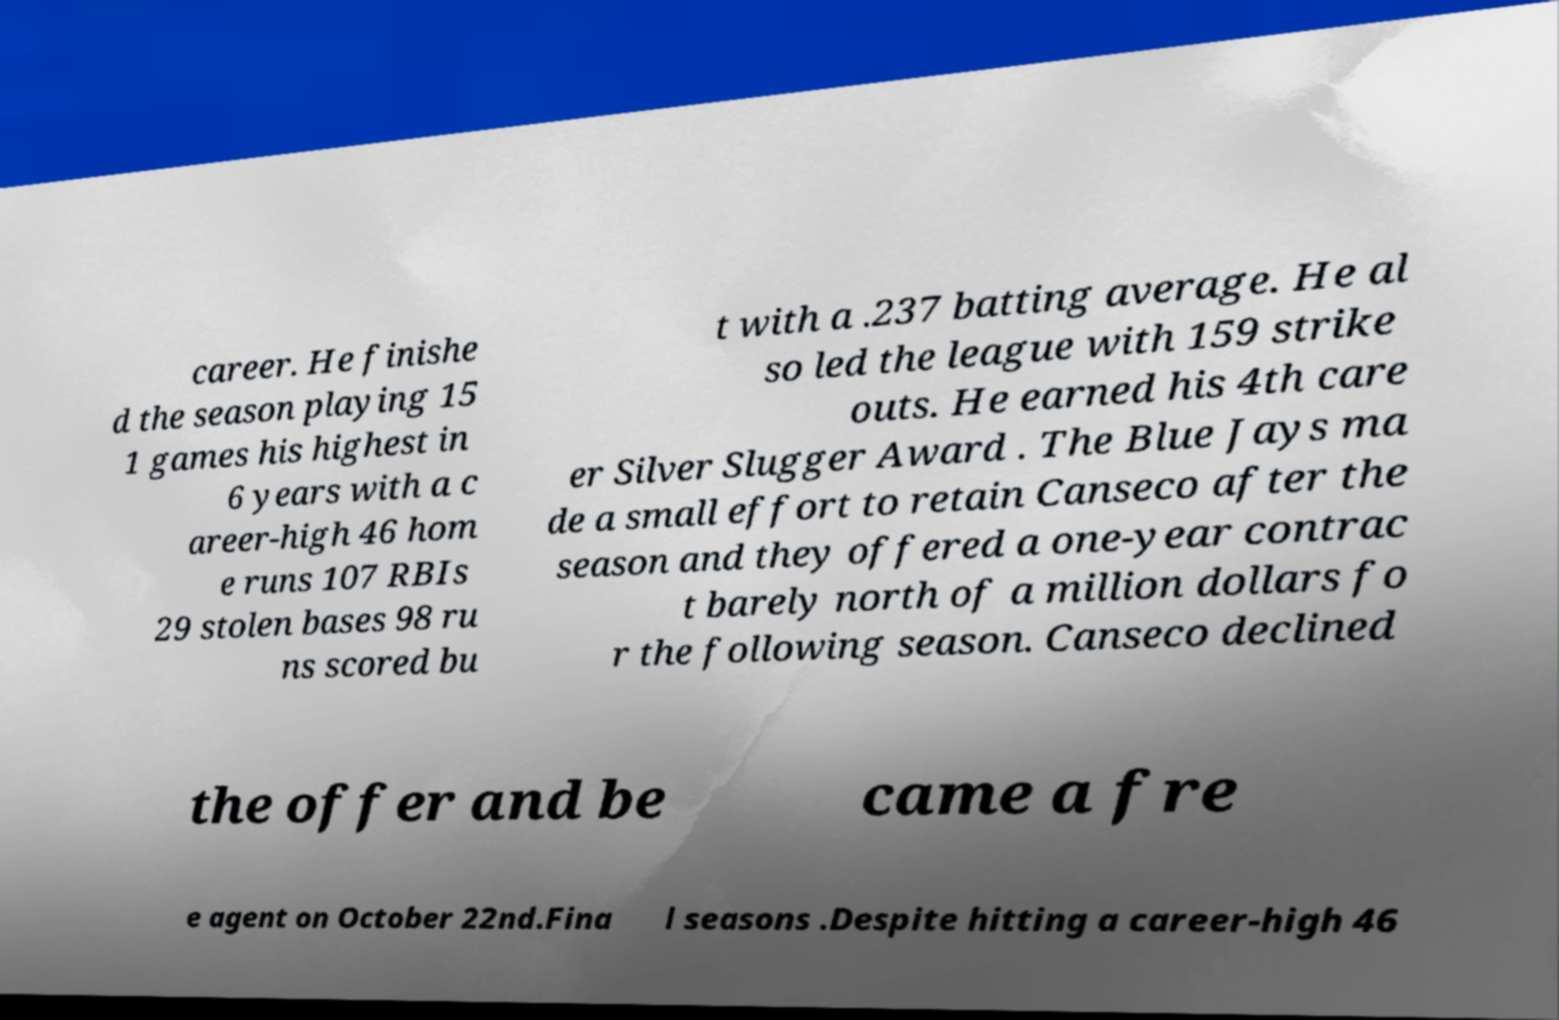I need the written content from this picture converted into text. Can you do that? career. He finishe d the season playing 15 1 games his highest in 6 years with a c areer-high 46 hom e runs 107 RBIs 29 stolen bases 98 ru ns scored bu t with a .237 batting average. He al so led the league with 159 strike outs. He earned his 4th care er Silver Slugger Award . The Blue Jays ma de a small effort to retain Canseco after the season and they offered a one-year contrac t barely north of a million dollars fo r the following season. Canseco declined the offer and be came a fre e agent on October 22nd.Fina l seasons .Despite hitting a career-high 46 